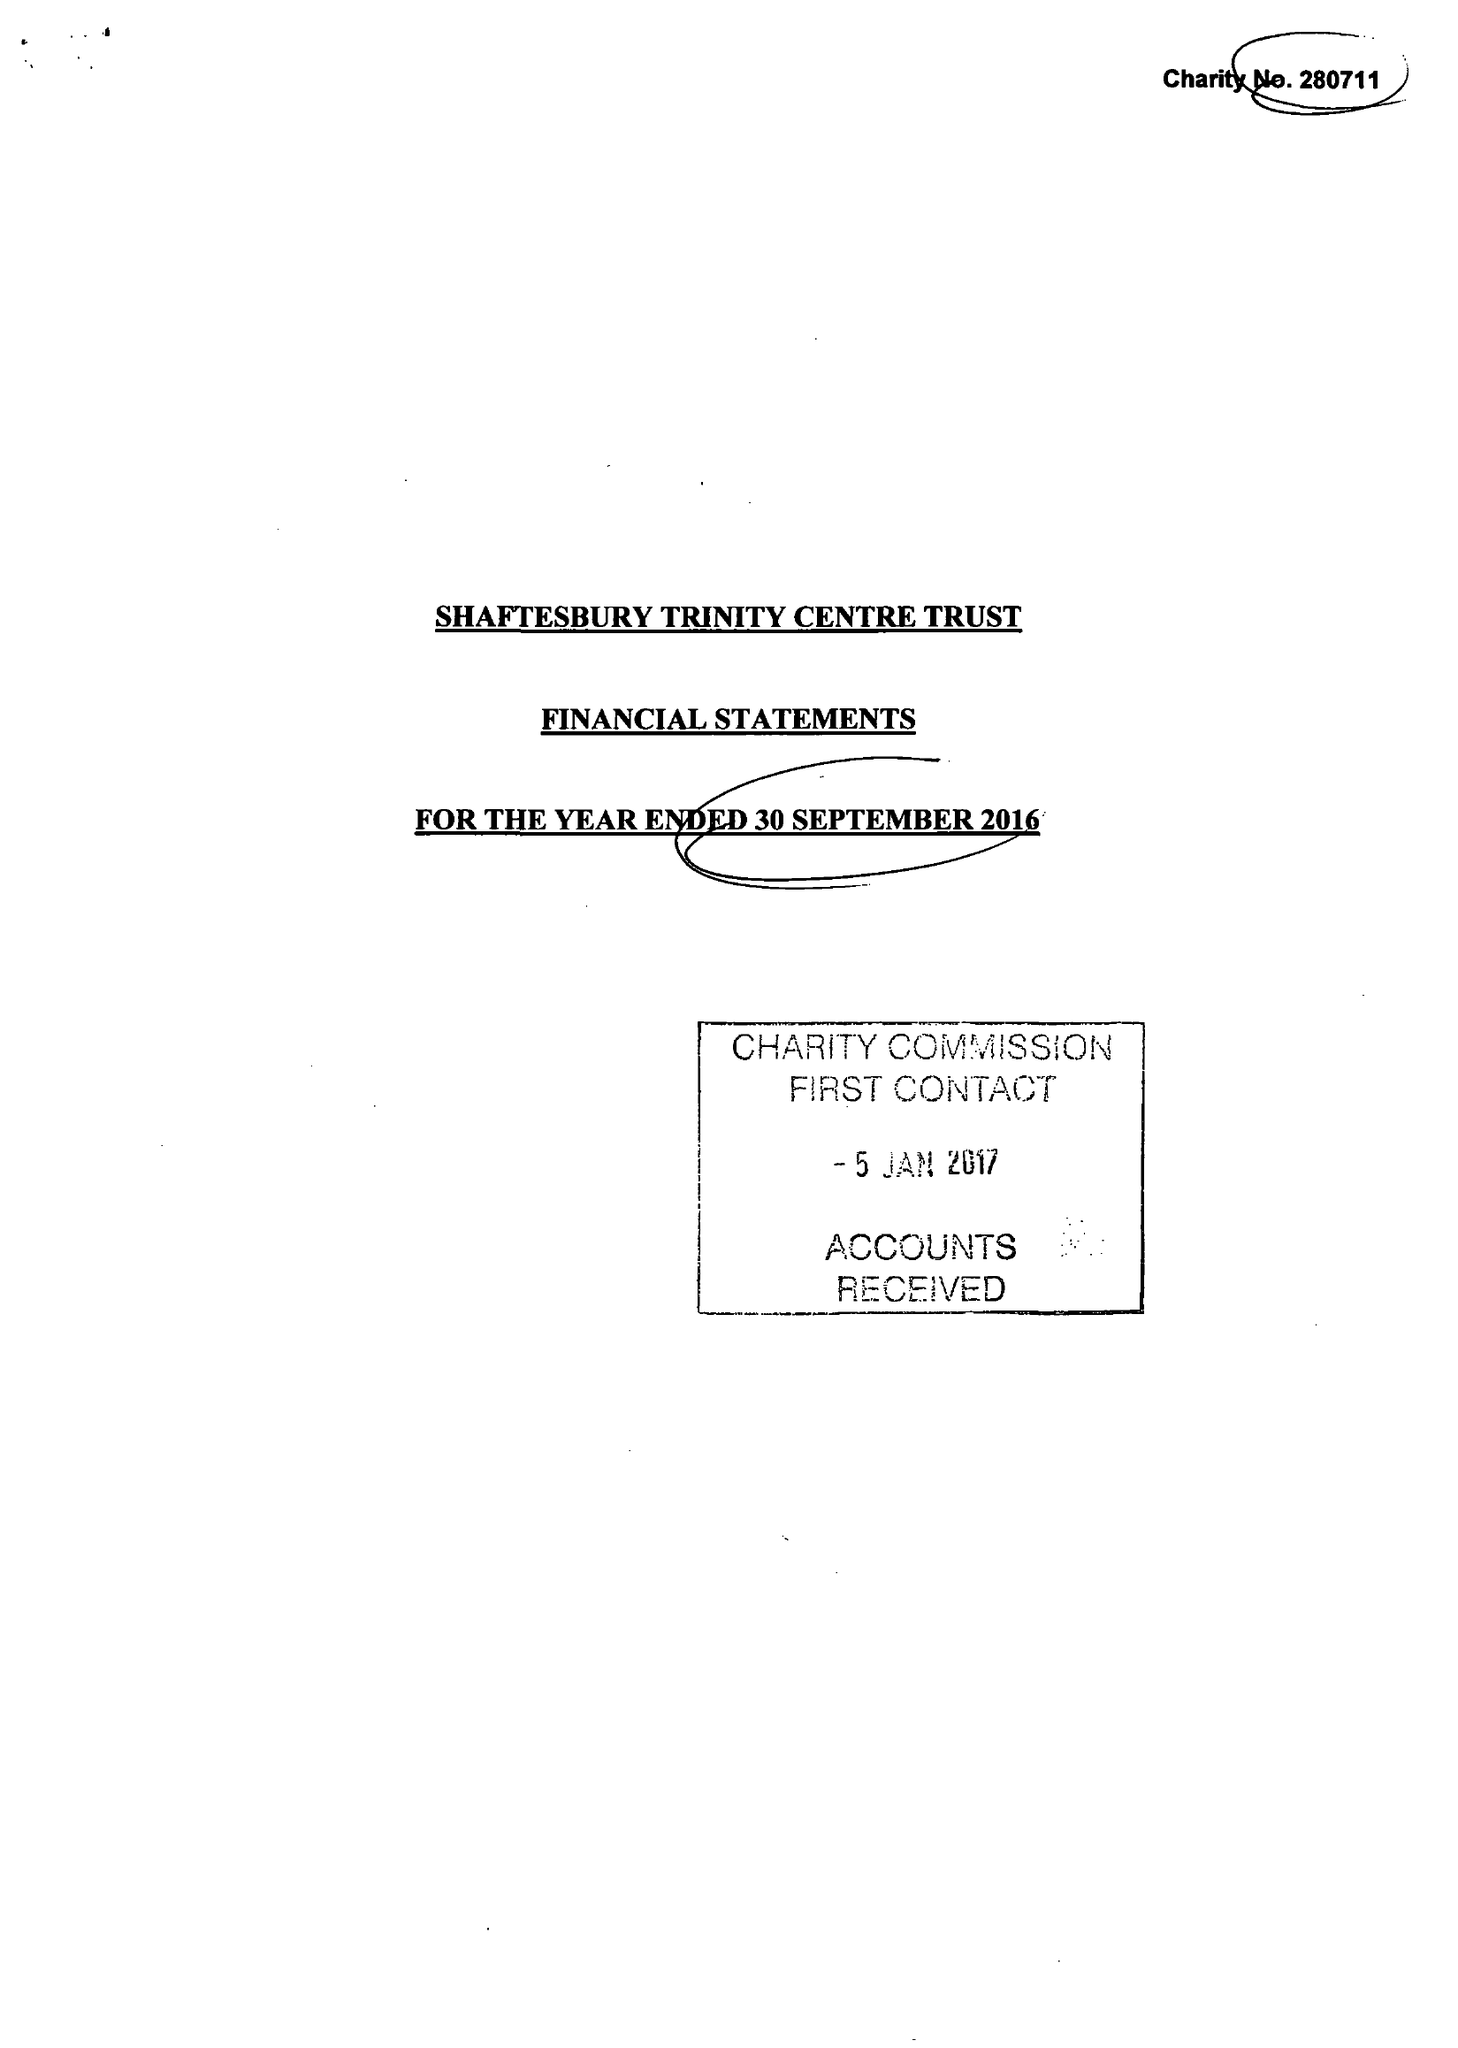What is the value for the charity_number?
Answer the question using a single word or phrase. 280711 